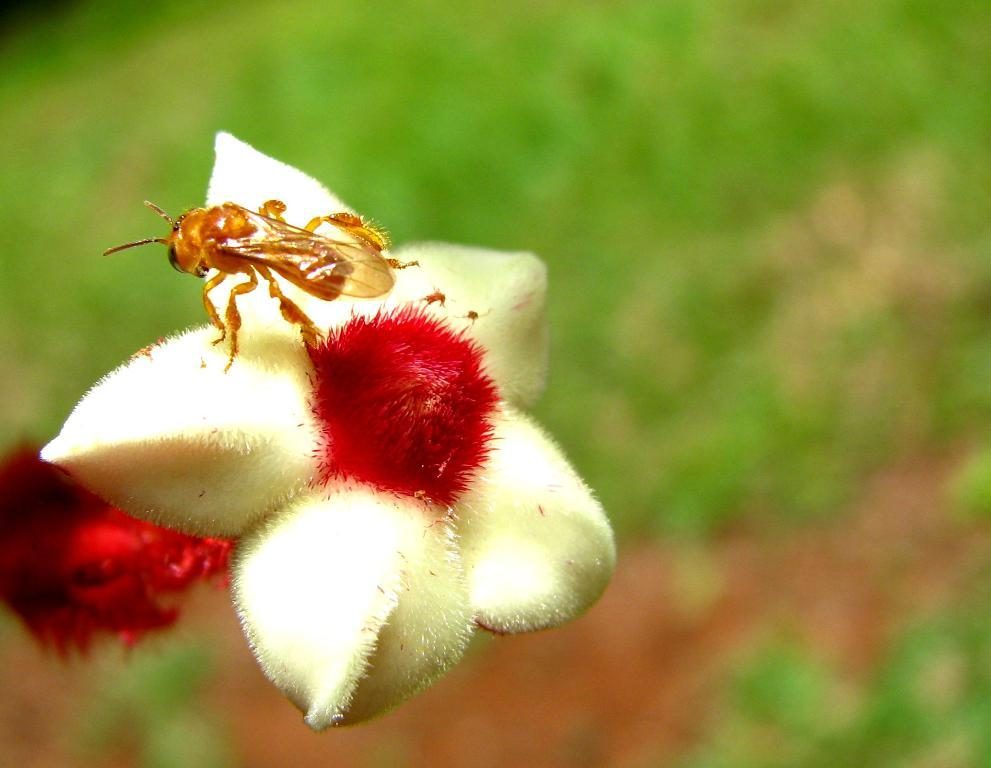What is present in the image that is not a human or a common object? There is a bug in the image. Where is the bug located in the image? The bug is on a flower. How many brothers does the bug have in the image? There is no information about the bug's family in the image. Can you tell me how far the bug can stretch in the image? There is no information about the bug's abilities or actions in the image. 